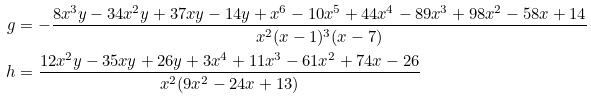<formula> <loc_0><loc_0><loc_500><loc_500>g & = - \frac { 8 x ^ { 3 } y - 3 4 x ^ { 2 } y + 3 7 x y - 1 4 y + x ^ { 6 } - 1 0 x ^ { 5 } + 4 4 x ^ { 4 } - 8 9 x ^ { 3 } + 9 8 x ^ { 2 } - 5 8 x + 1 4 } { x ^ { 2 } ( x - 1 ) ^ { 3 } ( x - 7 ) } \\ h & = \frac { 1 2 x ^ { 2 } y - 3 5 x y + 2 6 y + 3 x ^ { 4 } + 1 1 x ^ { 3 } - 6 1 x ^ { 2 } + 7 4 x - 2 6 } { x ^ { 2 } ( 9 x ^ { 2 } - 2 4 x + 1 3 ) }</formula> 